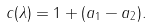Convert formula to latex. <formula><loc_0><loc_0><loc_500><loc_500>c ( \lambda ) = 1 + ( a _ { 1 } - a _ { 2 } ) .</formula> 